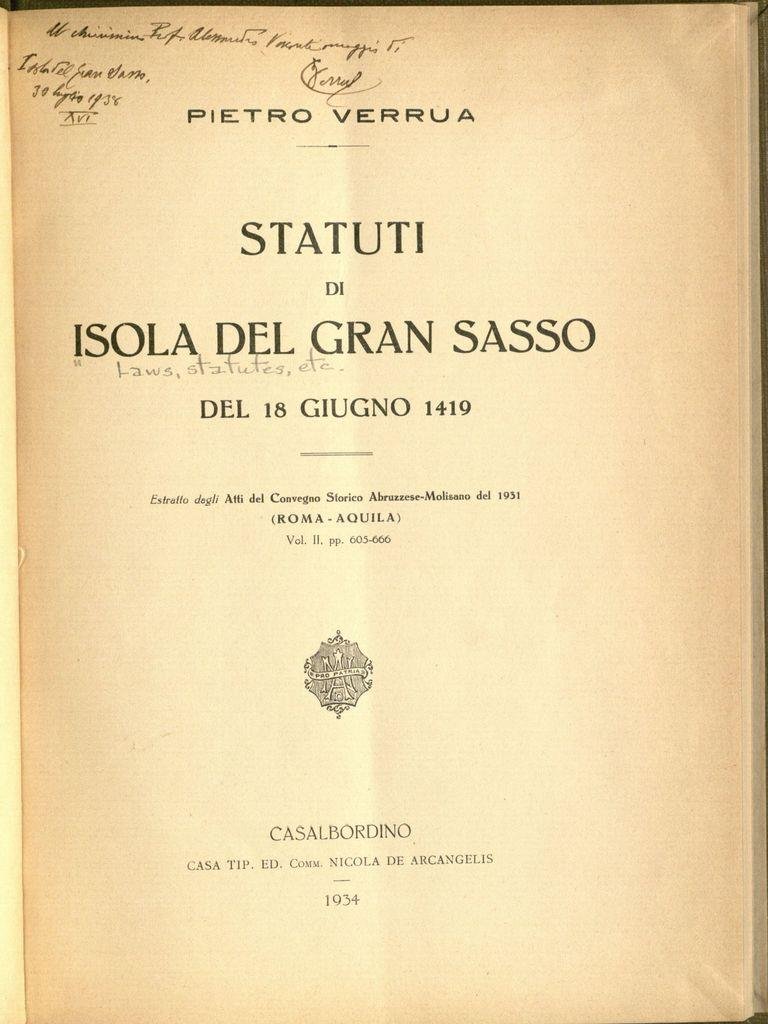<image>
Relay a brief, clear account of the picture shown. A book written in Italian open to its title page. 